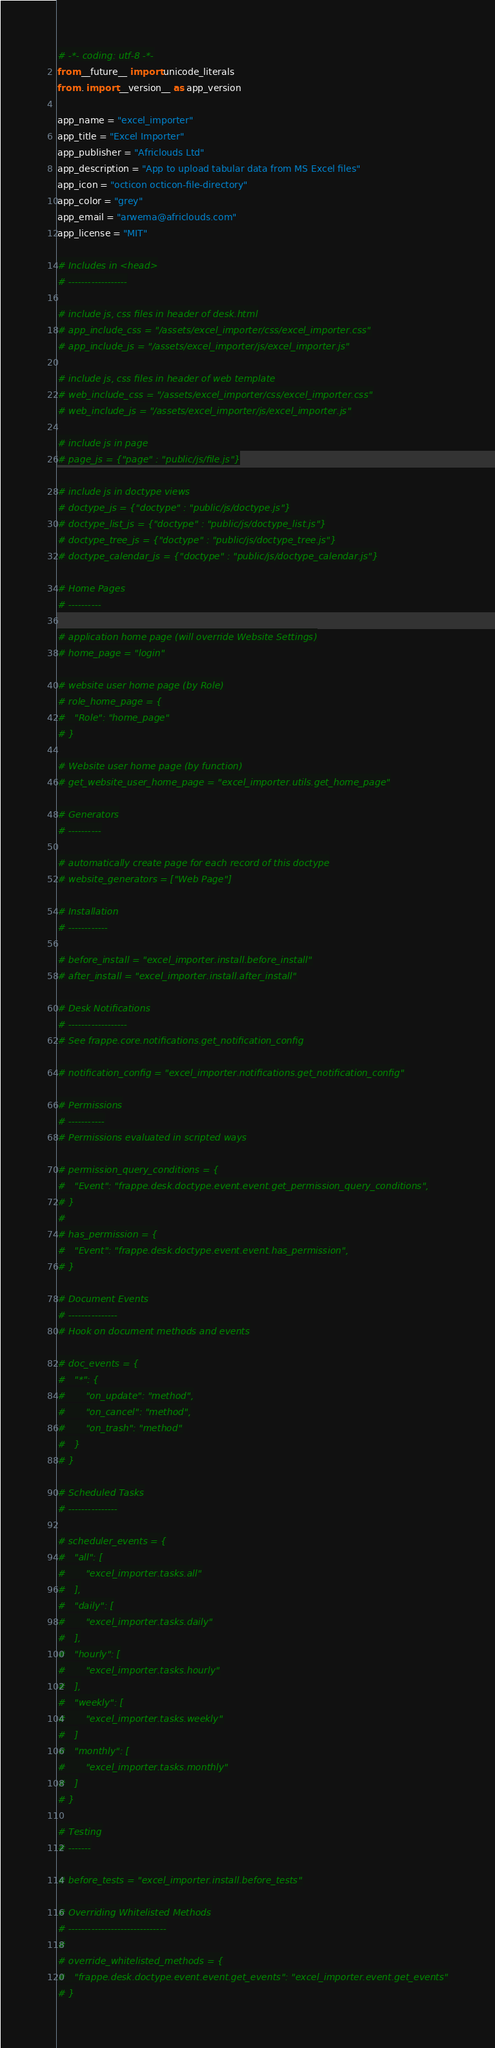<code> <loc_0><loc_0><loc_500><loc_500><_Python_># -*- coding: utf-8 -*-
from __future__ import unicode_literals
from . import __version__ as app_version

app_name = "excel_importer"
app_title = "Excel Importer"
app_publisher = "Africlouds Ltd"
app_description = "App to upload tabular data from MS Excel files"
app_icon = "octicon octicon-file-directory"
app_color = "grey"
app_email = "arwema@africlouds.com"
app_license = "MIT"

# Includes in <head>
# ------------------

# include js, css files in header of desk.html
# app_include_css = "/assets/excel_importer/css/excel_importer.css"
# app_include_js = "/assets/excel_importer/js/excel_importer.js"

# include js, css files in header of web template
# web_include_css = "/assets/excel_importer/css/excel_importer.css"
# web_include_js = "/assets/excel_importer/js/excel_importer.js"

# include js in page
# page_js = {"page" : "public/js/file.js"}

# include js in doctype views
# doctype_js = {"doctype" : "public/js/doctype.js"}
# doctype_list_js = {"doctype" : "public/js/doctype_list.js"}
# doctype_tree_js = {"doctype" : "public/js/doctype_tree.js"}
# doctype_calendar_js = {"doctype" : "public/js/doctype_calendar.js"}

# Home Pages
# ----------

# application home page (will override Website Settings)
# home_page = "login"

# website user home page (by Role)
# role_home_page = {
#	"Role": "home_page"
# }

# Website user home page (by function)
# get_website_user_home_page = "excel_importer.utils.get_home_page"

# Generators
# ----------

# automatically create page for each record of this doctype
# website_generators = ["Web Page"]

# Installation
# ------------

# before_install = "excel_importer.install.before_install"
# after_install = "excel_importer.install.after_install"

# Desk Notifications
# ------------------
# See frappe.core.notifications.get_notification_config

# notification_config = "excel_importer.notifications.get_notification_config"

# Permissions
# -----------
# Permissions evaluated in scripted ways

# permission_query_conditions = {
# 	"Event": "frappe.desk.doctype.event.event.get_permission_query_conditions",
# }
#
# has_permission = {
# 	"Event": "frappe.desk.doctype.event.event.has_permission",
# }

# Document Events
# ---------------
# Hook on document methods and events

# doc_events = {
# 	"*": {
# 		"on_update": "method",
# 		"on_cancel": "method",
# 		"on_trash": "method"
#	}
# }

# Scheduled Tasks
# ---------------

# scheduler_events = {
# 	"all": [
# 		"excel_importer.tasks.all"
# 	],
# 	"daily": [
# 		"excel_importer.tasks.daily"
# 	],
# 	"hourly": [
# 		"excel_importer.tasks.hourly"
# 	],
# 	"weekly": [
# 		"excel_importer.tasks.weekly"
# 	]
# 	"monthly": [
# 		"excel_importer.tasks.monthly"
# 	]
# }

# Testing
# -------

# before_tests = "excel_importer.install.before_tests"

# Overriding Whitelisted Methods
# ------------------------------
#
# override_whitelisted_methods = {
# 	"frappe.desk.doctype.event.event.get_events": "excel_importer.event.get_events"
# }

</code> 